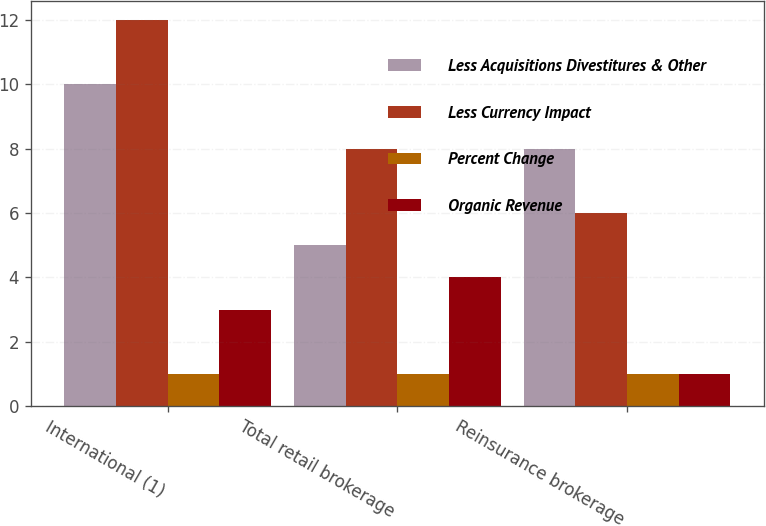Convert chart. <chart><loc_0><loc_0><loc_500><loc_500><stacked_bar_chart><ecel><fcel>International (1)<fcel>Total retail brokerage<fcel>Reinsurance brokerage<nl><fcel>Less Acquisitions Divestitures & Other<fcel>10<fcel>5<fcel>8<nl><fcel>Less Currency Impact<fcel>12<fcel>8<fcel>6<nl><fcel>Percent Change<fcel>1<fcel>1<fcel>1<nl><fcel>Organic Revenue<fcel>3<fcel>4<fcel>1<nl></chart> 